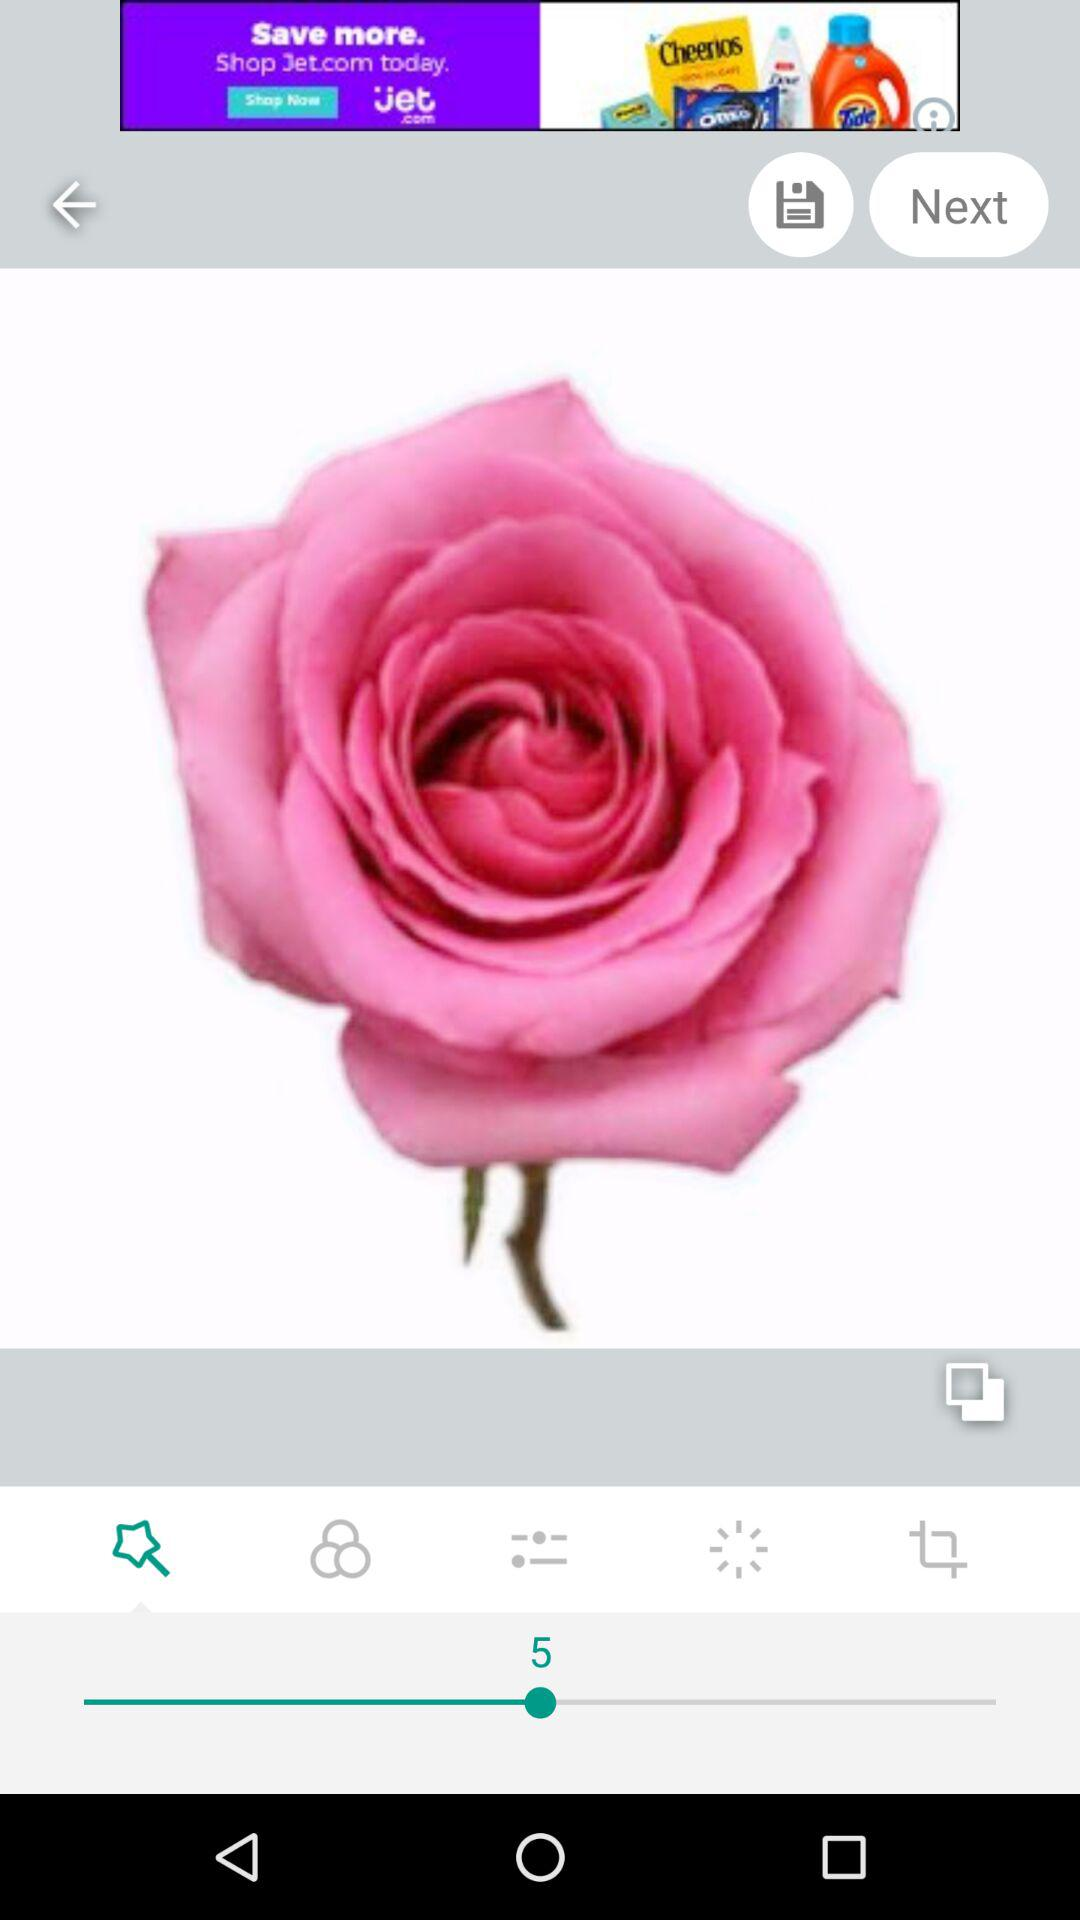What is the selected value? The selected value is 5. 